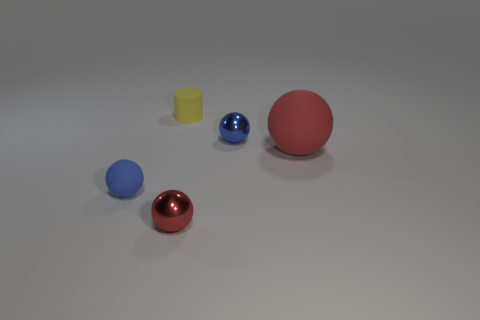What is the color of the big object that is the same shape as the tiny blue rubber object?
Give a very brief answer. Red. What size is the other red object that is the same shape as the large matte thing?
Provide a succinct answer. Small. There is a tiny thing that is in front of the large rubber sphere and behind the small red object; what is it made of?
Provide a short and direct response. Rubber. Does the small metallic thing that is behind the small blue rubber sphere have the same color as the small rubber ball?
Give a very brief answer. Yes. There is a large rubber sphere; does it have the same color as the metallic object that is in front of the blue metallic ball?
Keep it short and to the point. Yes. Are there any small shiny balls to the left of the red matte thing?
Your answer should be very brief. Yes. Do the yellow cylinder and the small red thing have the same material?
Keep it short and to the point. No. What material is the yellow cylinder that is the same size as the blue matte thing?
Offer a very short reply. Rubber. What number of objects are big rubber spheres behind the small red thing or small rubber cylinders?
Offer a very short reply. 2. Are there the same number of tiny matte things that are behind the blue rubber object and small blue rubber things?
Provide a succinct answer. Yes. 